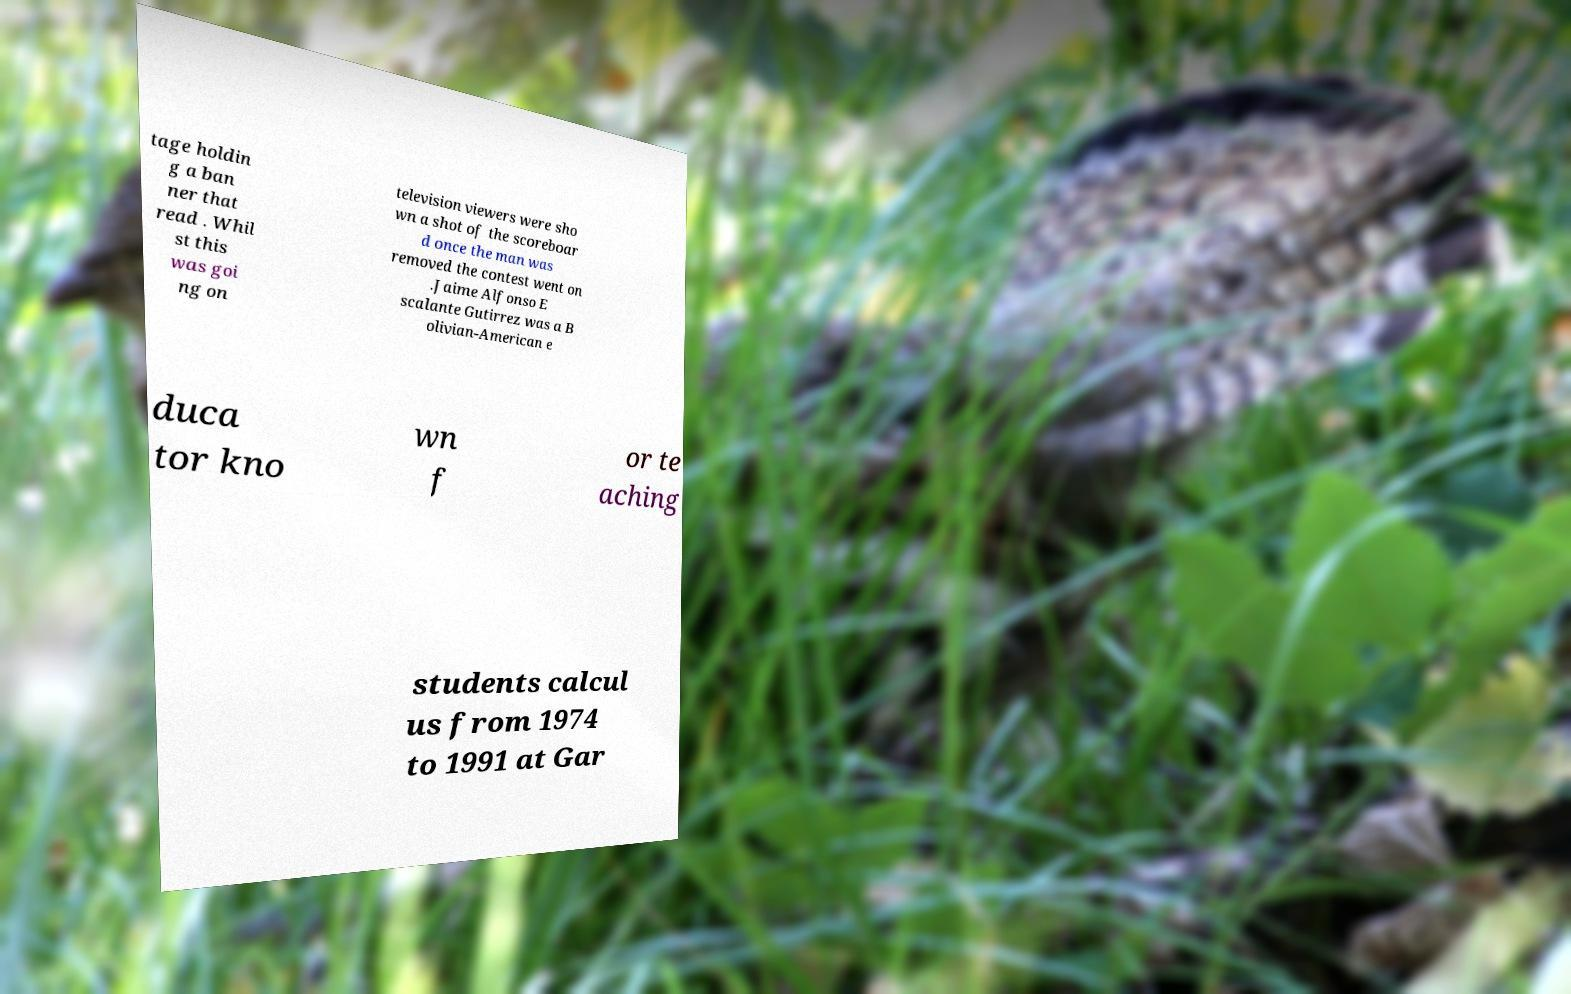What messages or text are displayed in this image? I need them in a readable, typed format. tage holdin g a ban ner that read . Whil st this was goi ng on television viewers were sho wn a shot of the scoreboar d once the man was removed the contest went on .Jaime Alfonso E scalante Gutirrez was a B olivian-American e duca tor kno wn f or te aching students calcul us from 1974 to 1991 at Gar 